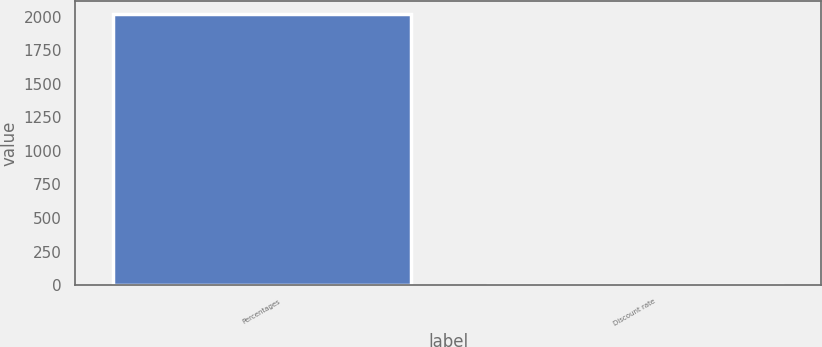Convert chart. <chart><loc_0><loc_0><loc_500><loc_500><bar_chart><fcel>Percentages<fcel>Discount rate<nl><fcel>2016<fcel>4<nl></chart> 